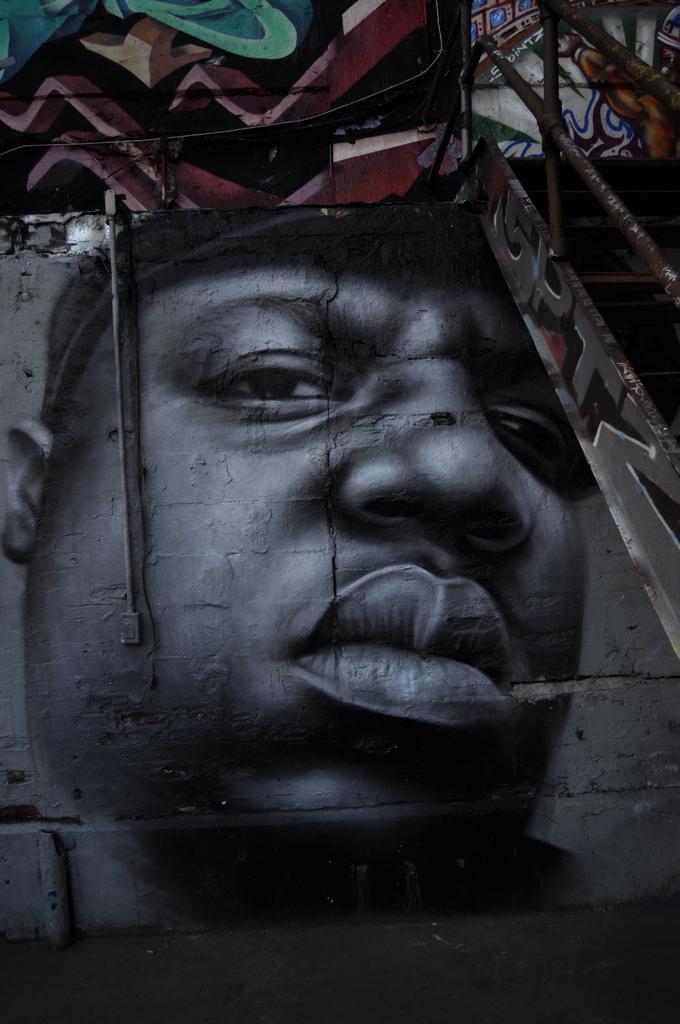How would you summarize this image in a sentence or two? It is an edited image of a man, on the right side it is an iron fence. 